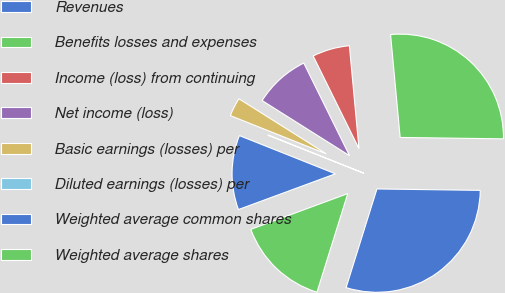Convert chart. <chart><loc_0><loc_0><loc_500><loc_500><pie_chart><fcel>Revenues<fcel>Benefits losses and expenses<fcel>Income (loss) from continuing<fcel>Net income (loss)<fcel>Basic earnings (losses) per<fcel>Diluted earnings (losses) per<fcel>Weighted average common shares<fcel>Weighted average shares<nl><fcel>29.61%<fcel>26.7%<fcel>5.83%<fcel>8.74%<fcel>2.92%<fcel>0.01%<fcel>11.65%<fcel>14.56%<nl></chart> 